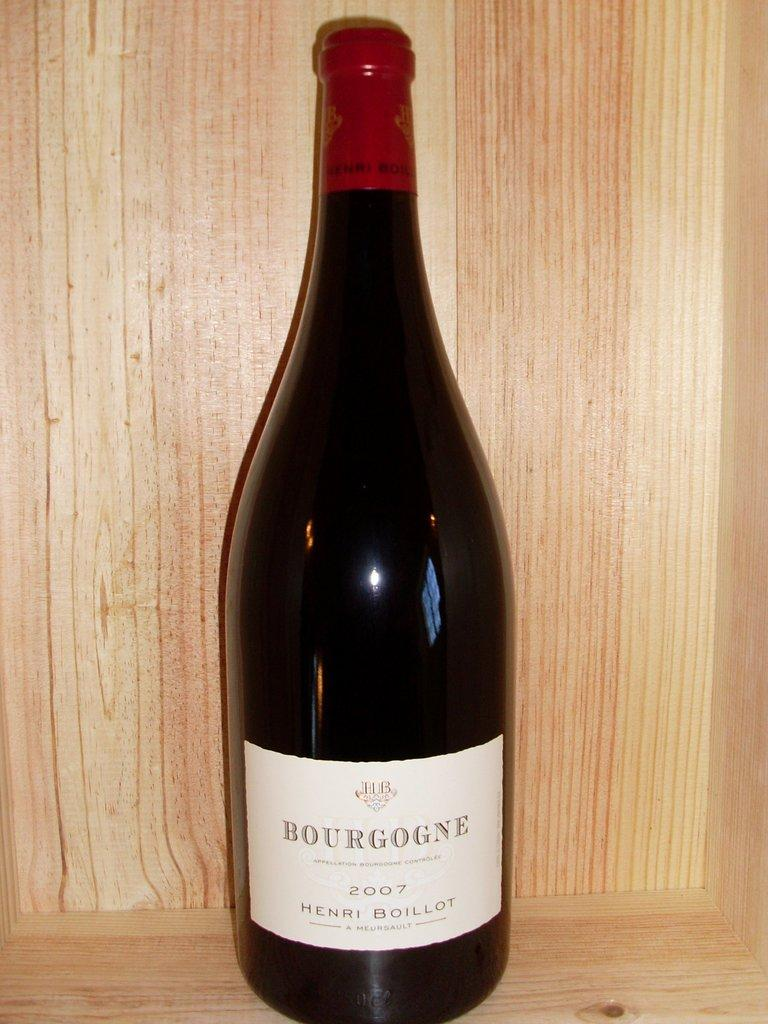<image>
Share a concise interpretation of the image provided. A bottle has a label with the year 2007 and is on a wood surface. 